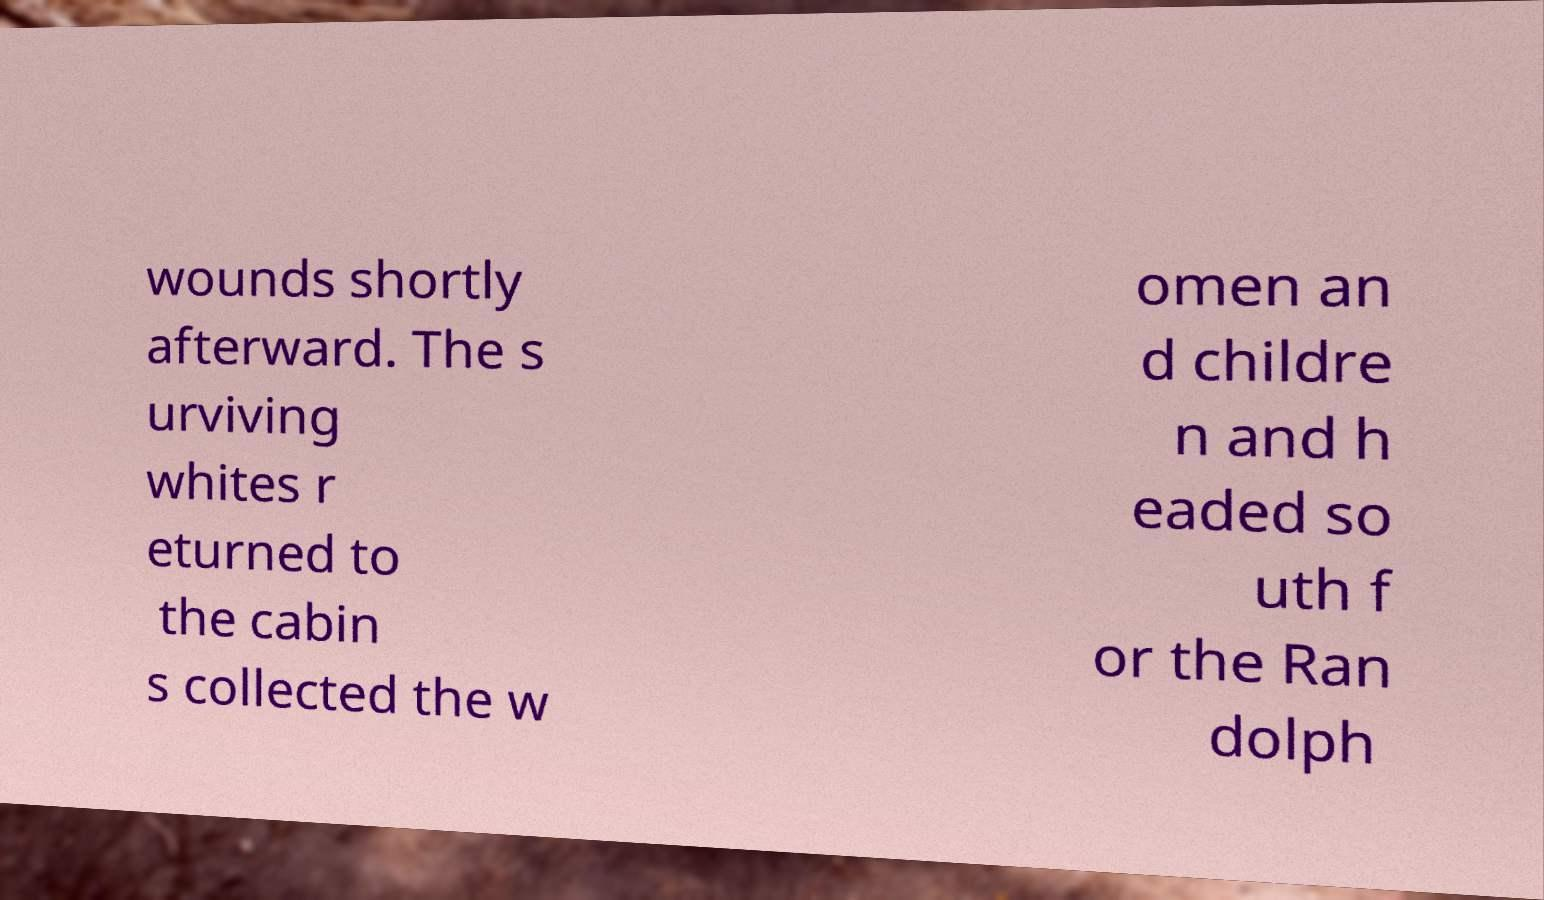I need the written content from this picture converted into text. Can you do that? wounds shortly afterward. The s urviving whites r eturned to the cabin s collected the w omen an d childre n and h eaded so uth f or the Ran dolph 